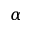<formula> <loc_0><loc_0><loc_500><loc_500>\alpha</formula> 